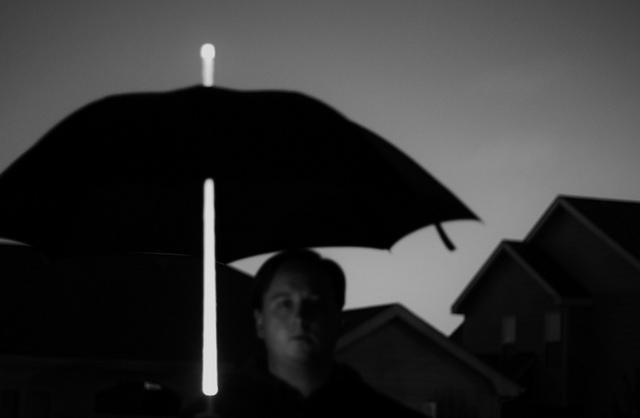Is the handle of the umbrella a light saver?
Keep it brief. Yes. What is the weather like?
Concise answer only. Rainy. How many umbrellas are there?
Quick response, please. 1. Who is depicted on the umbrella on the left?
Be succinct. Man. What color is the sky?
Write a very short answer. Gray. Is the umbrella open?
Keep it brief. Yes. Is a woman or a man holding the umbrella?
Give a very brief answer. Man. Has this umbrella been abandoned?
Keep it brief. No. 